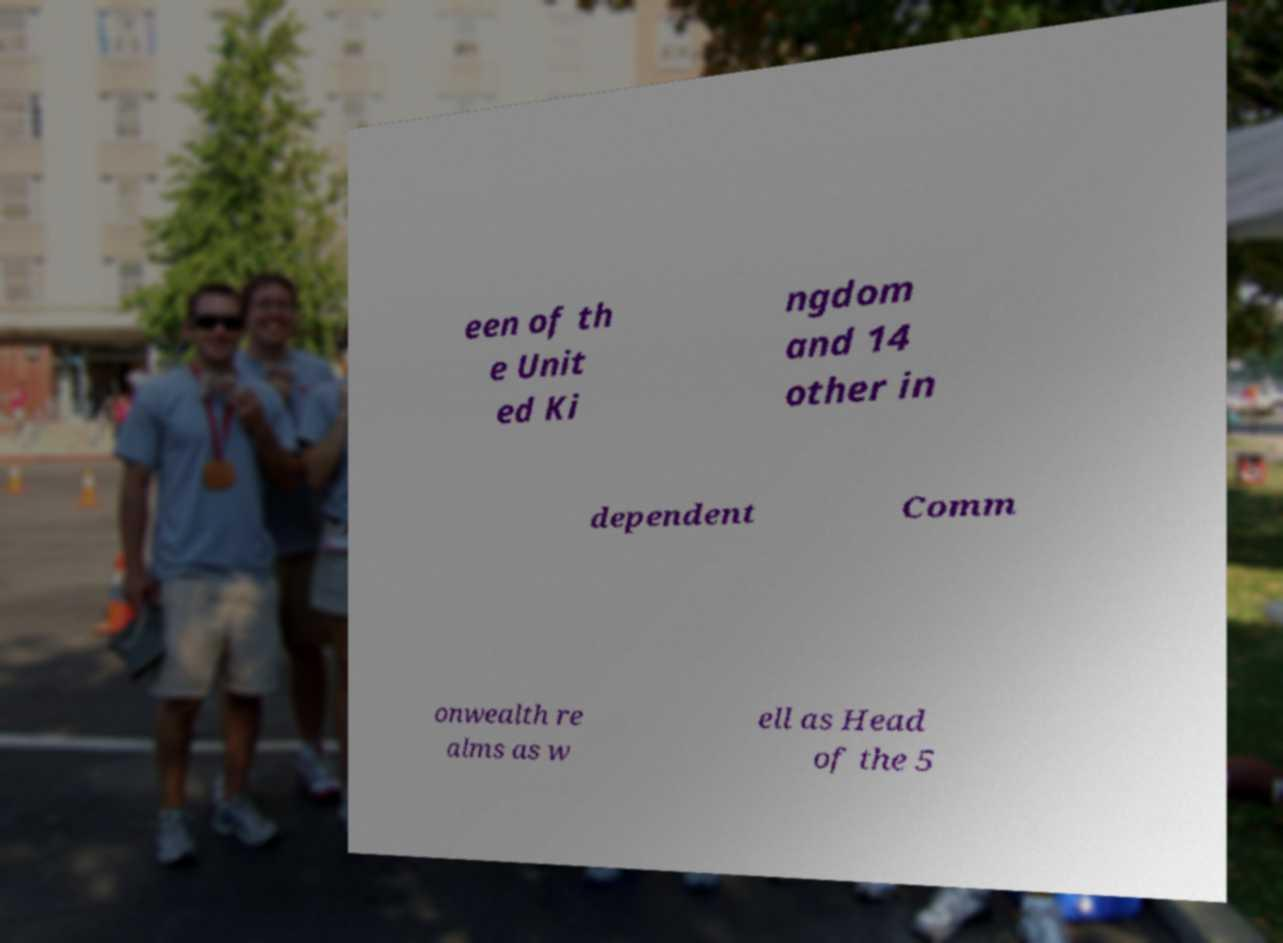Can you accurately transcribe the text from the provided image for me? een of th e Unit ed Ki ngdom and 14 other in dependent Comm onwealth re alms as w ell as Head of the 5 